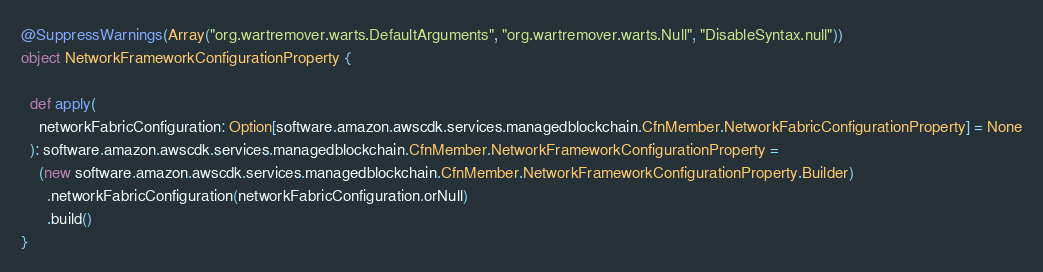<code> <loc_0><loc_0><loc_500><loc_500><_Scala_>
@SuppressWarnings(Array("org.wartremover.warts.DefaultArguments", "org.wartremover.warts.Null", "DisableSyntax.null"))
object NetworkFrameworkConfigurationProperty {

  def apply(
    networkFabricConfiguration: Option[software.amazon.awscdk.services.managedblockchain.CfnMember.NetworkFabricConfigurationProperty] = None
  ): software.amazon.awscdk.services.managedblockchain.CfnMember.NetworkFrameworkConfigurationProperty =
    (new software.amazon.awscdk.services.managedblockchain.CfnMember.NetworkFrameworkConfigurationProperty.Builder)
      .networkFabricConfiguration(networkFabricConfiguration.orNull)
      .build()
}
</code> 